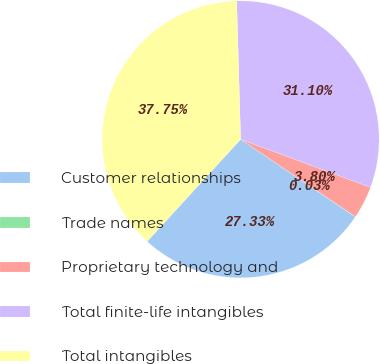Convert chart to OTSL. <chart><loc_0><loc_0><loc_500><loc_500><pie_chart><fcel>Customer relationships<fcel>Trade names<fcel>Proprietary technology and<fcel>Total finite-life intangibles<fcel>Total intangibles<nl><fcel>27.33%<fcel>0.03%<fcel>3.8%<fcel>31.1%<fcel>37.75%<nl></chart> 